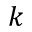Convert formula to latex. <formula><loc_0><loc_0><loc_500><loc_500>k</formula> 